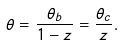Convert formula to latex. <formula><loc_0><loc_0><loc_500><loc_500>\theta = \frac { \theta _ { b } } { 1 - z } = \frac { \theta _ { c } } { z } .</formula> 